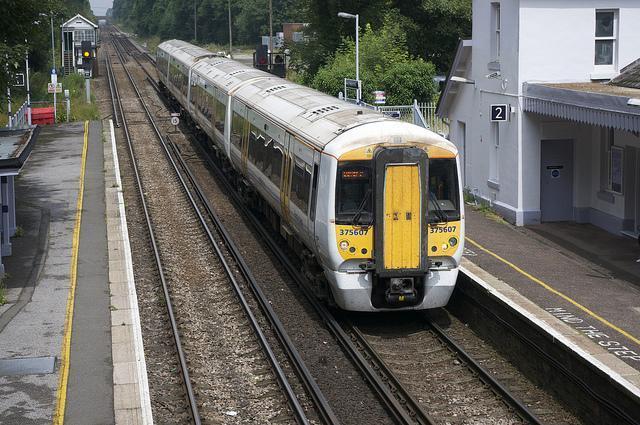How many sets of tracks are there?
Give a very brief answer. 2. How many men are clean shaven?
Give a very brief answer. 0. 